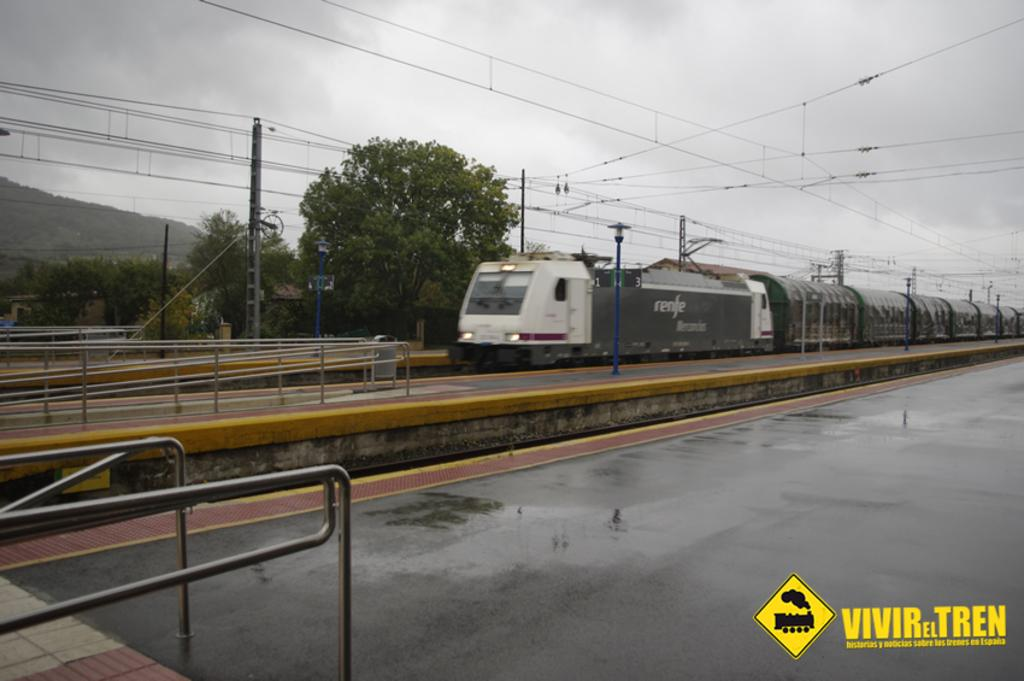What is the main structure in the image? There is a platform in the image. What type of fencing can be seen in the image? There are iron grills in the image. What mode of transportation is present on the railway track? A train is present on the railway track. What type of poles are visible in the image? There are street poles and electric poles in the image. What is attached to the street poles? Street lights are visible in the image. What is connected to the electric poles? Electric cables are visible in the image. What type of vegetation is present in the image? Trees are present in the image. What is visible in the sky? The sky is visible in the image, and clouds are visible in the sky. What type of chair is being used by the clouds in the image? There are no chairs present in the image, and the clouds are not using any chairs. 